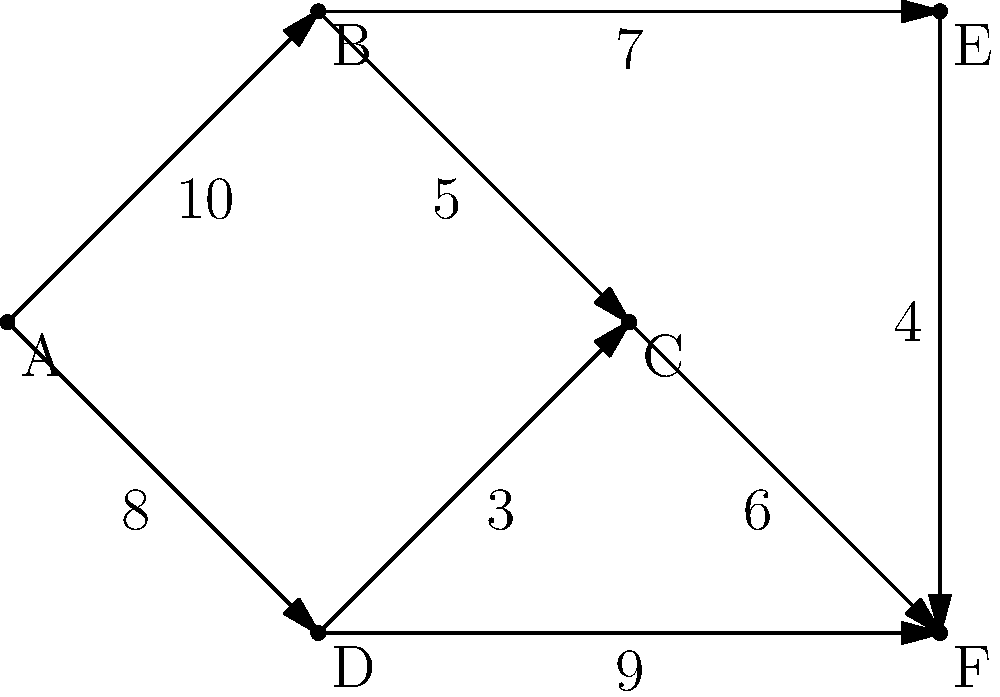As a successful engineer tasked with optimizing a complex transportation network, you are presented with the directed graph above representing a flow network. The vertices represent junctions, and the edges represent one-way routes with their respective capacities (in units/hour). If A is the source and F is the sink, what is the maximum flow that can be achieved from A to F? To solve this problem, we'll use the Ford-Fulkerson algorithm to find the maximum flow:

1. Initialize flow to 0.

2. Find an augmenting path from A to F:
   Path 1: A -> B -> E -> F (min capacity: 4)
   Increase flow by 4. New flow: 4

3. Update residual graph and find another path:
   Path 2: A -> D -> F (min capacity: 8)
   Increase flow by 8. New flow: 12

4. Update residual graph and find another path:
   Path 3: A -> B -> C -> F (min capacity: 5)
   Increase flow by 5. New flow: 17

5. Update residual graph and find another path:
   Path 4: A -> D -> C -> F (min capacity: 1)
   Increase flow by 1. New flow: 18

6. No more augmenting paths exist.

Therefore, the maximum flow from A to F is 18 units/hour.

This solution utilizes the concept of finding augmenting paths and updating the residual graph, which is crucial in network flow problems. As an experienced engineer, understanding and applying these algorithms is essential for optimizing complex systems.
Answer: 18 units/hour 